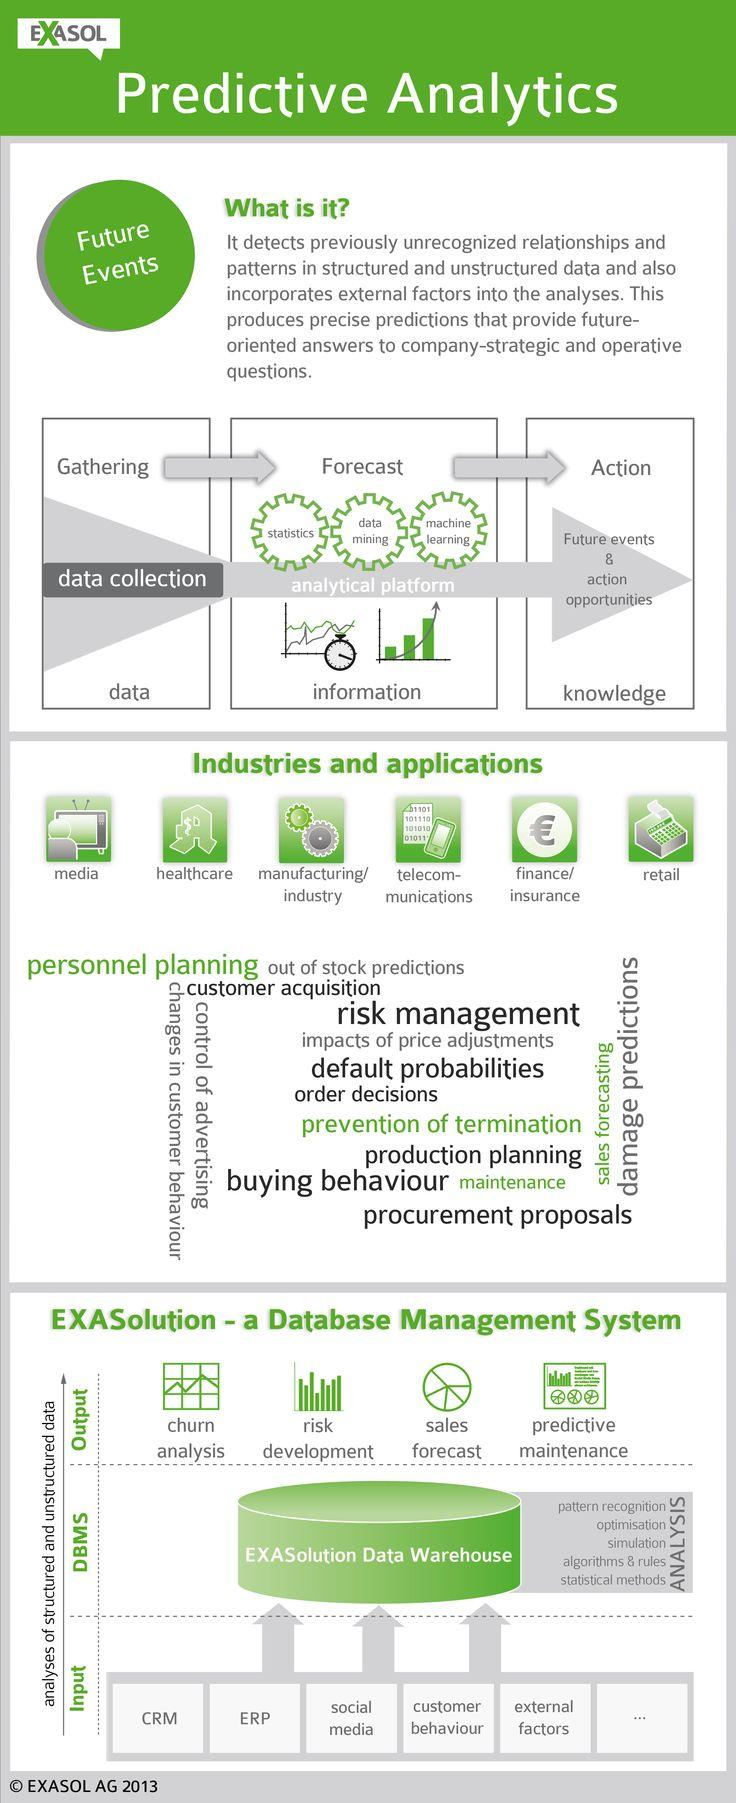List a handful of essential elements in this visual. The infographic contains five inputs. The infographic contains 4 outputs. The EXASolution Data warehouse has performed 5 analyses. 